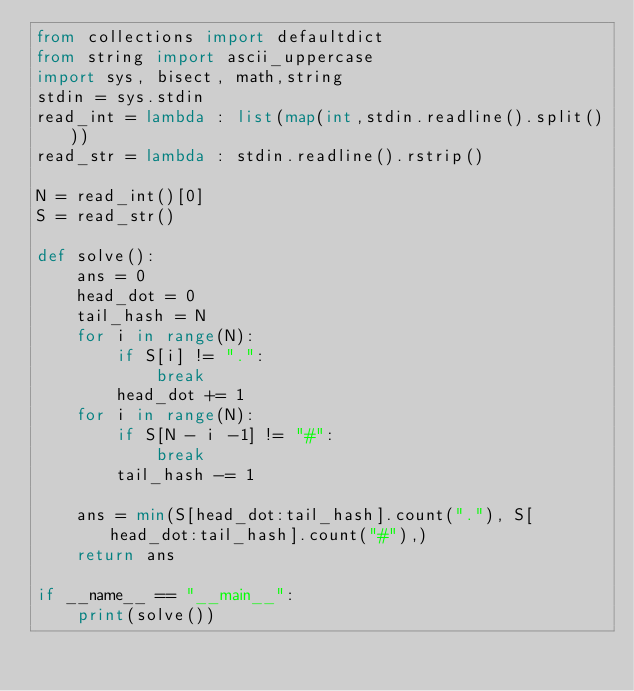Convert code to text. <code><loc_0><loc_0><loc_500><loc_500><_Python_>from collections import defaultdict
from string import ascii_uppercase
import sys, bisect, math,string
stdin = sys.stdin
read_int = lambda : list(map(int,stdin.readline().split()))
read_str = lambda : stdin.readline().rstrip()

N = read_int()[0]
S = read_str()

def solve():
    ans = 0
    head_dot = 0
    tail_hash = N
    for i in range(N):
        if S[i] != ".":
            break
        head_dot += 1
    for i in range(N):
        if S[N - i -1] != "#":
            break
        tail_hash -= 1

    ans = min(S[head_dot:tail_hash].count("."), S[head_dot:tail_hash].count("#"),)
    return ans

if __name__ == "__main__":
    print(solve())
</code> 